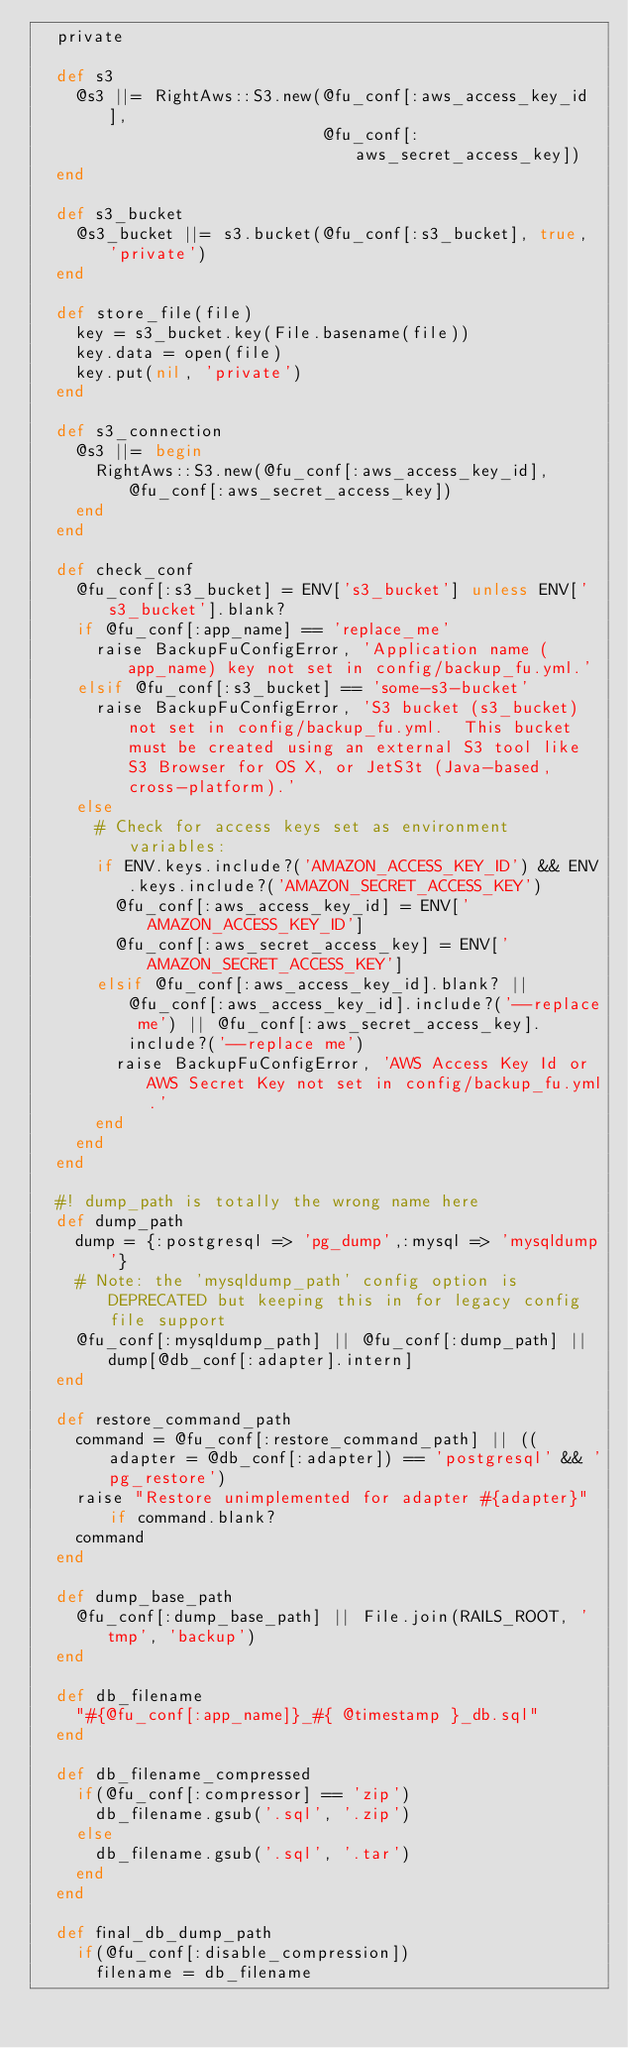<code> <loc_0><loc_0><loc_500><loc_500><_Ruby_>  private
  
  def s3
    @s3 ||= RightAws::S3.new(@fu_conf[:aws_access_key_id],
                             @fu_conf[:aws_secret_access_key])
  end
  
  def s3_bucket
    @s3_bucket ||= s3.bucket(@fu_conf[:s3_bucket], true, 'private')
  end
  
  def store_file(file)
    key = s3_bucket.key(File.basename(file))
    key.data = open(file)
    key.put(nil, 'private')
  end
  
  def s3_connection
    @s3 ||= begin
      RightAws::S3.new(@fu_conf[:aws_access_key_id], @fu_conf[:aws_secret_access_key])
    end
  end

  def check_conf
    @fu_conf[:s3_bucket] = ENV['s3_bucket'] unless ENV['s3_bucket'].blank?
    if @fu_conf[:app_name] == 'replace_me'
      raise BackupFuConfigError, 'Application name (app_name) key not set in config/backup_fu.yml.'
    elsif @fu_conf[:s3_bucket] == 'some-s3-bucket'
      raise BackupFuConfigError, 'S3 bucket (s3_bucket) not set in config/backup_fu.yml.  This bucket must be created using an external S3 tool like S3 Browser for OS X, or JetS3t (Java-based, cross-platform).'
    else
      # Check for access keys set as environment variables:
      if ENV.keys.include?('AMAZON_ACCESS_KEY_ID') && ENV.keys.include?('AMAZON_SECRET_ACCESS_KEY')
        @fu_conf[:aws_access_key_id] = ENV['AMAZON_ACCESS_KEY_ID']
        @fu_conf[:aws_secret_access_key] = ENV['AMAZON_SECRET_ACCESS_KEY']
      elsif @fu_conf[:aws_access_key_id].blank? || @fu_conf[:aws_access_key_id].include?('--replace me') || @fu_conf[:aws_secret_access_key].include?('--replace me')
        raise BackupFuConfigError, 'AWS Access Key Id or AWS Secret Key not set in config/backup_fu.yml.'
      end
    end
  end
  
  #! dump_path is totally the wrong name here
  def dump_path
    dump = {:postgresql => 'pg_dump',:mysql => 'mysqldump'}
    # Note: the 'mysqldump_path' config option is DEPRECATED but keeping this in for legacy config file support
    @fu_conf[:mysqldump_path] || @fu_conf[:dump_path] || dump[@db_conf[:adapter].intern]
  end

  def restore_command_path
    command = @fu_conf[:restore_command_path] || ((adapter = @db_conf[:adapter]) == 'postgresql' && 'pg_restore')
    raise "Restore unimplemented for adapter #{adapter}" if command.blank?
    command
  end

  def dump_base_path
    @fu_conf[:dump_base_path] || File.join(RAILS_ROOT, 'tmp', 'backup')
  end
  
  def db_filename
    "#{@fu_conf[:app_name]}_#{ @timestamp }_db.sql"
  end

  def db_filename_compressed
    if(@fu_conf[:compressor] == 'zip')
      db_filename.gsub('.sql', '.zip')
    else
      db_filename.gsub('.sql', '.tar')
    end
  end

  def final_db_dump_path
    if(@fu_conf[:disable_compression])
      filename = db_filename</code> 